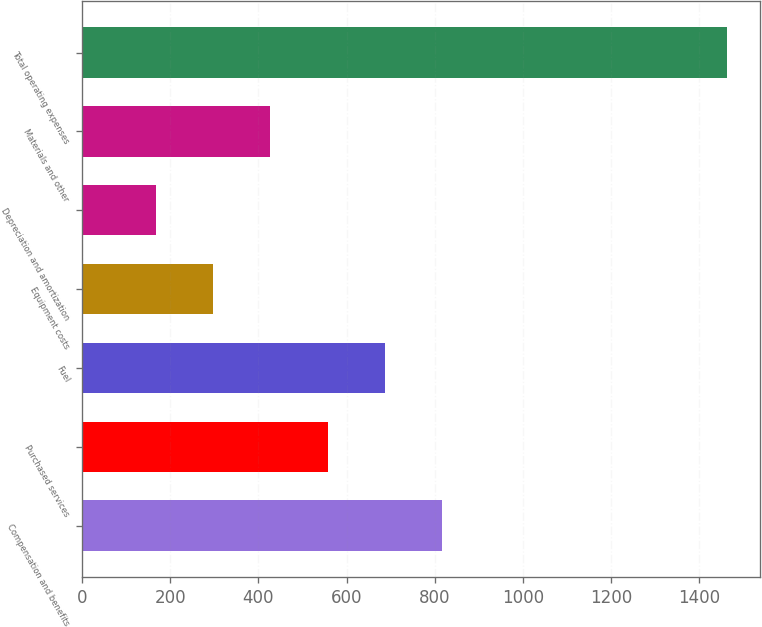<chart> <loc_0><loc_0><loc_500><loc_500><bar_chart><fcel>Compensation and benefits<fcel>Purchased services<fcel>Fuel<fcel>Equipment costs<fcel>Depreciation and amortization<fcel>Materials and other<fcel>Total operating expenses<nl><fcel>816.25<fcel>556.87<fcel>686.56<fcel>297.49<fcel>167.8<fcel>427.18<fcel>1464.7<nl></chart> 